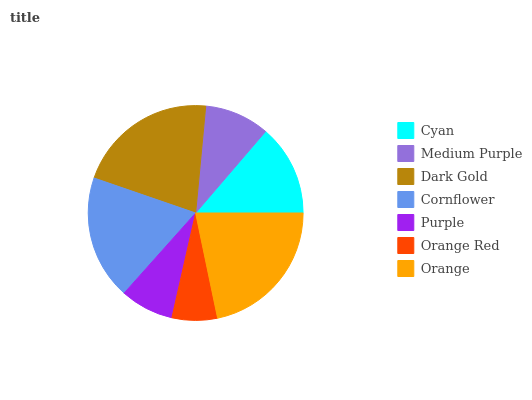Is Orange Red the minimum?
Answer yes or no. Yes. Is Orange the maximum?
Answer yes or no. Yes. Is Medium Purple the minimum?
Answer yes or no. No. Is Medium Purple the maximum?
Answer yes or no. No. Is Cyan greater than Medium Purple?
Answer yes or no. Yes. Is Medium Purple less than Cyan?
Answer yes or no. Yes. Is Medium Purple greater than Cyan?
Answer yes or no. No. Is Cyan less than Medium Purple?
Answer yes or no. No. Is Cyan the high median?
Answer yes or no. Yes. Is Cyan the low median?
Answer yes or no. Yes. Is Medium Purple the high median?
Answer yes or no. No. Is Medium Purple the low median?
Answer yes or no. No. 